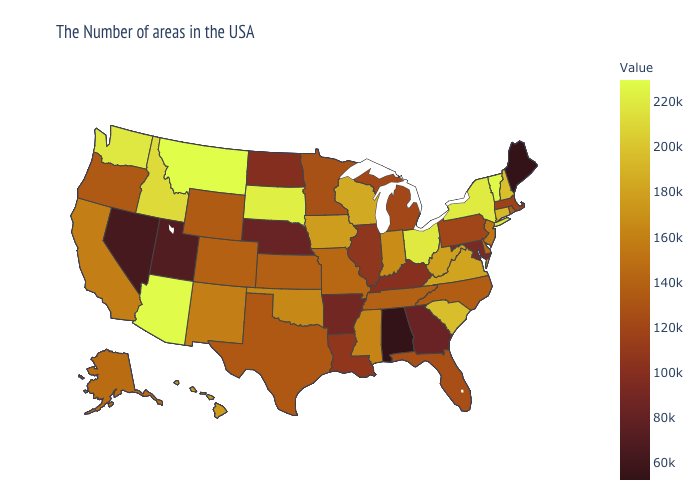Which states have the lowest value in the Northeast?
Write a very short answer. Maine. Which states have the highest value in the USA?
Answer briefly. Montana. Among the states that border Oregon , which have the lowest value?
Keep it brief. Nevada. Which states have the lowest value in the USA?
Write a very short answer. Maine, Alabama. Is the legend a continuous bar?
Keep it brief. Yes. 